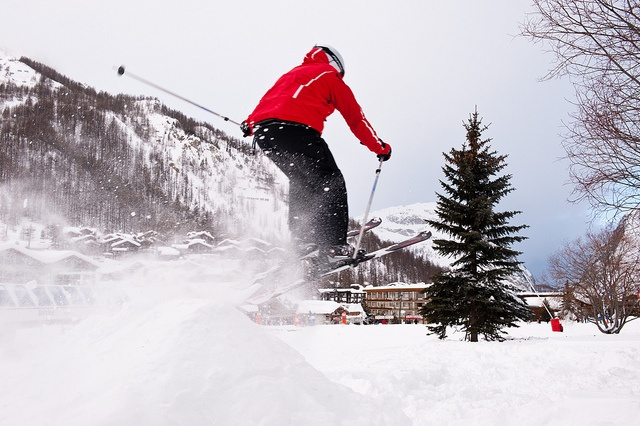Describe the objects in this image and their specific colors. I can see people in white, black, brown, and gray tones and skis in white, lightgray, gray, darkgray, and black tones in this image. 